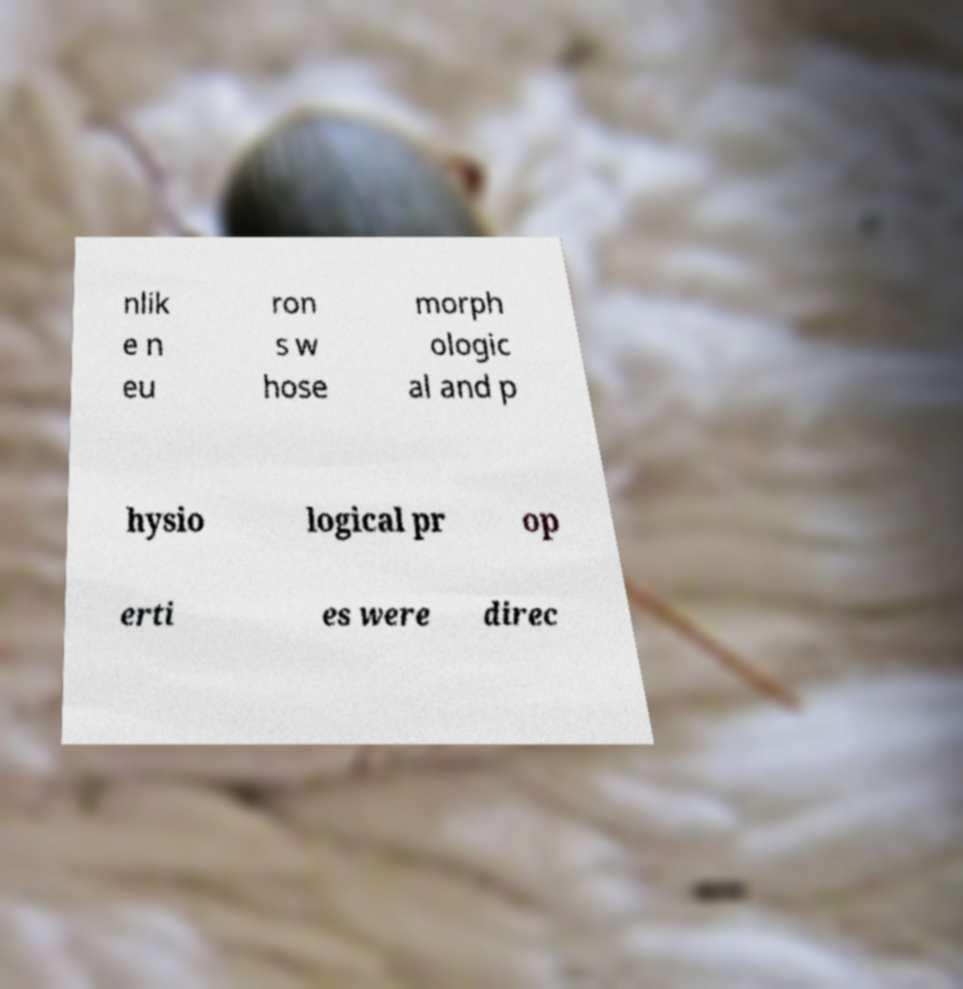Could you assist in decoding the text presented in this image and type it out clearly? nlik e n eu ron s w hose morph ologic al and p hysio logical pr op erti es were direc 